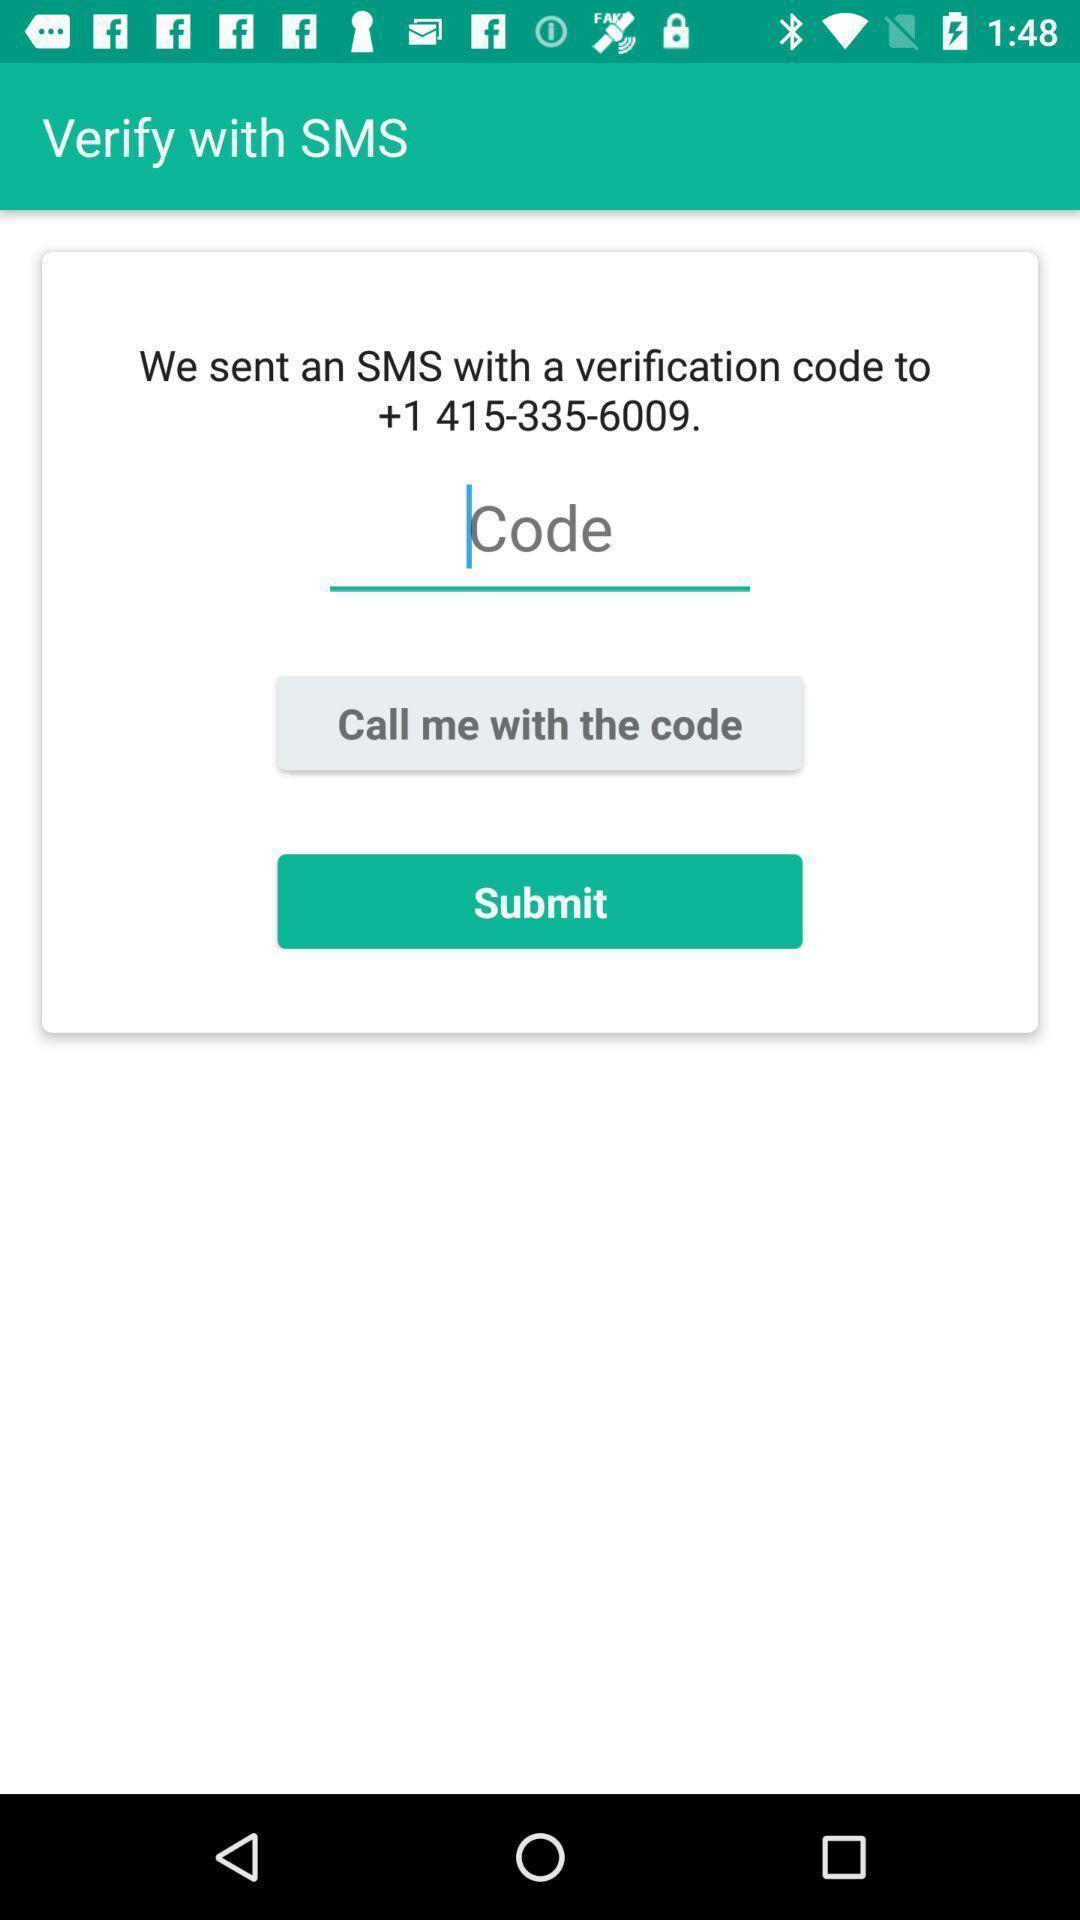Explain the elements present in this screenshot. Verification page. 